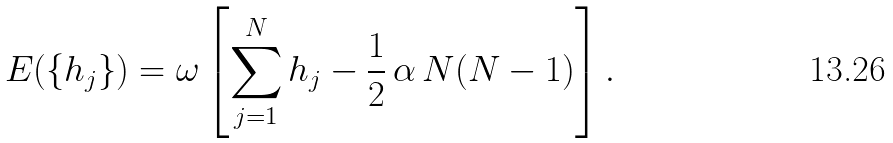Convert formula to latex. <formula><loc_0><loc_0><loc_500><loc_500>E ( \{ h _ { j } \} ) = \omega \left [ \sum _ { j = 1 } ^ { N } h _ { j } - \frac { 1 } { 2 } \, \alpha \, N ( N - 1 ) \right ] .</formula> 